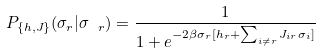Convert formula to latex. <formula><loc_0><loc_0><loc_500><loc_500>P _ { \{ h , J \} } ( \sigma _ { r } | \sigma _ { \ r } ) = \frac { 1 } { 1 + e ^ { - 2 \beta \sigma _ { r } [ h _ { r } + \sum _ { i \neq r } { J _ { i r } \sigma _ { i } } ] } } \</formula> 